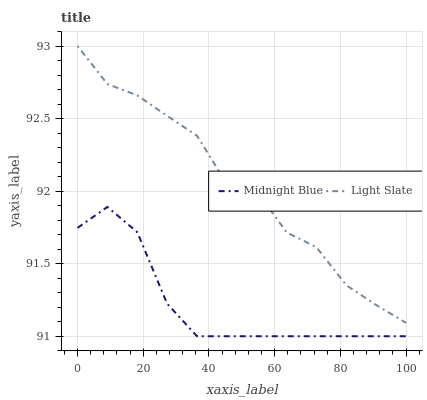Does Midnight Blue have the maximum area under the curve?
Answer yes or no. No. Is Midnight Blue the roughest?
Answer yes or no. No. Does Midnight Blue have the highest value?
Answer yes or no. No. Is Midnight Blue less than Light Slate?
Answer yes or no. Yes. Is Light Slate greater than Midnight Blue?
Answer yes or no. Yes. Does Midnight Blue intersect Light Slate?
Answer yes or no. No. 